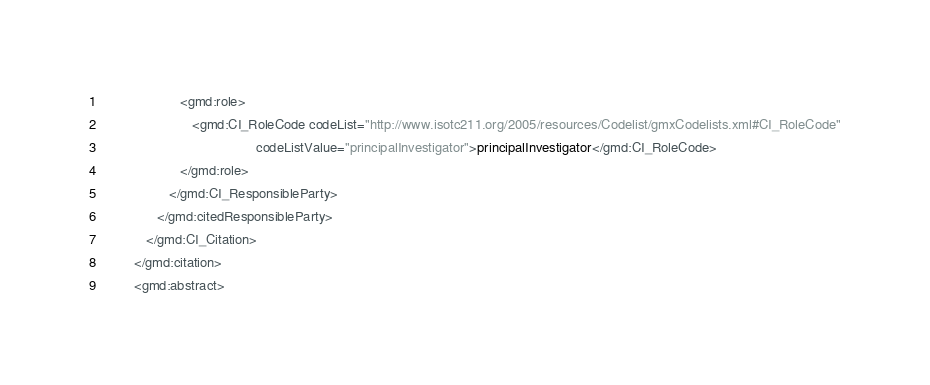<code> <loc_0><loc_0><loc_500><loc_500><_XML_>                     <gmd:role>
                        <gmd:CI_RoleCode codeList="http://www.isotc211.org/2005/resources/Codelist/gmxCodelists.xml#CI_RoleCode"
                                         codeListValue="principalInvestigator">principalInvestigator</gmd:CI_RoleCode>
                     </gmd:role>
                  </gmd:CI_ResponsibleParty>
               </gmd:citedResponsibleParty>
            </gmd:CI_Citation>
         </gmd:citation>
         <gmd:abstract></code> 